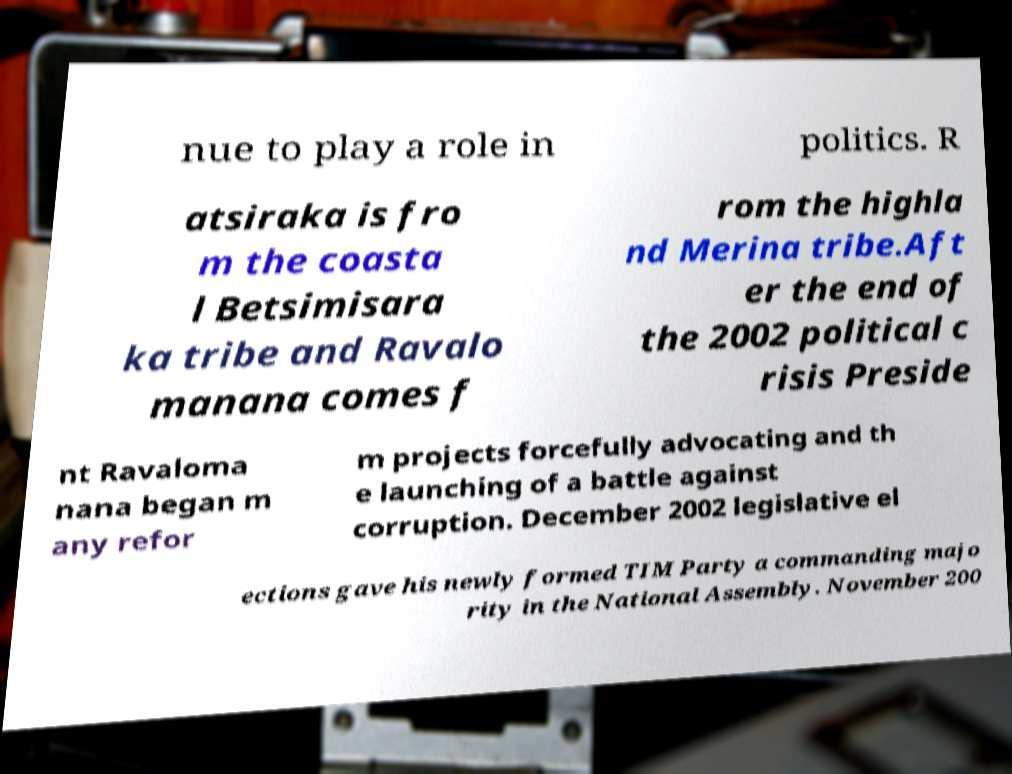What messages or text are displayed in this image? I need them in a readable, typed format. nue to play a role in politics. R atsiraka is fro m the coasta l Betsimisara ka tribe and Ravalo manana comes f rom the highla nd Merina tribe.Aft er the end of the 2002 political c risis Preside nt Ravaloma nana began m any refor m projects forcefully advocating and th e launching of a battle against corruption. December 2002 legislative el ections gave his newly formed TIM Party a commanding majo rity in the National Assembly. November 200 